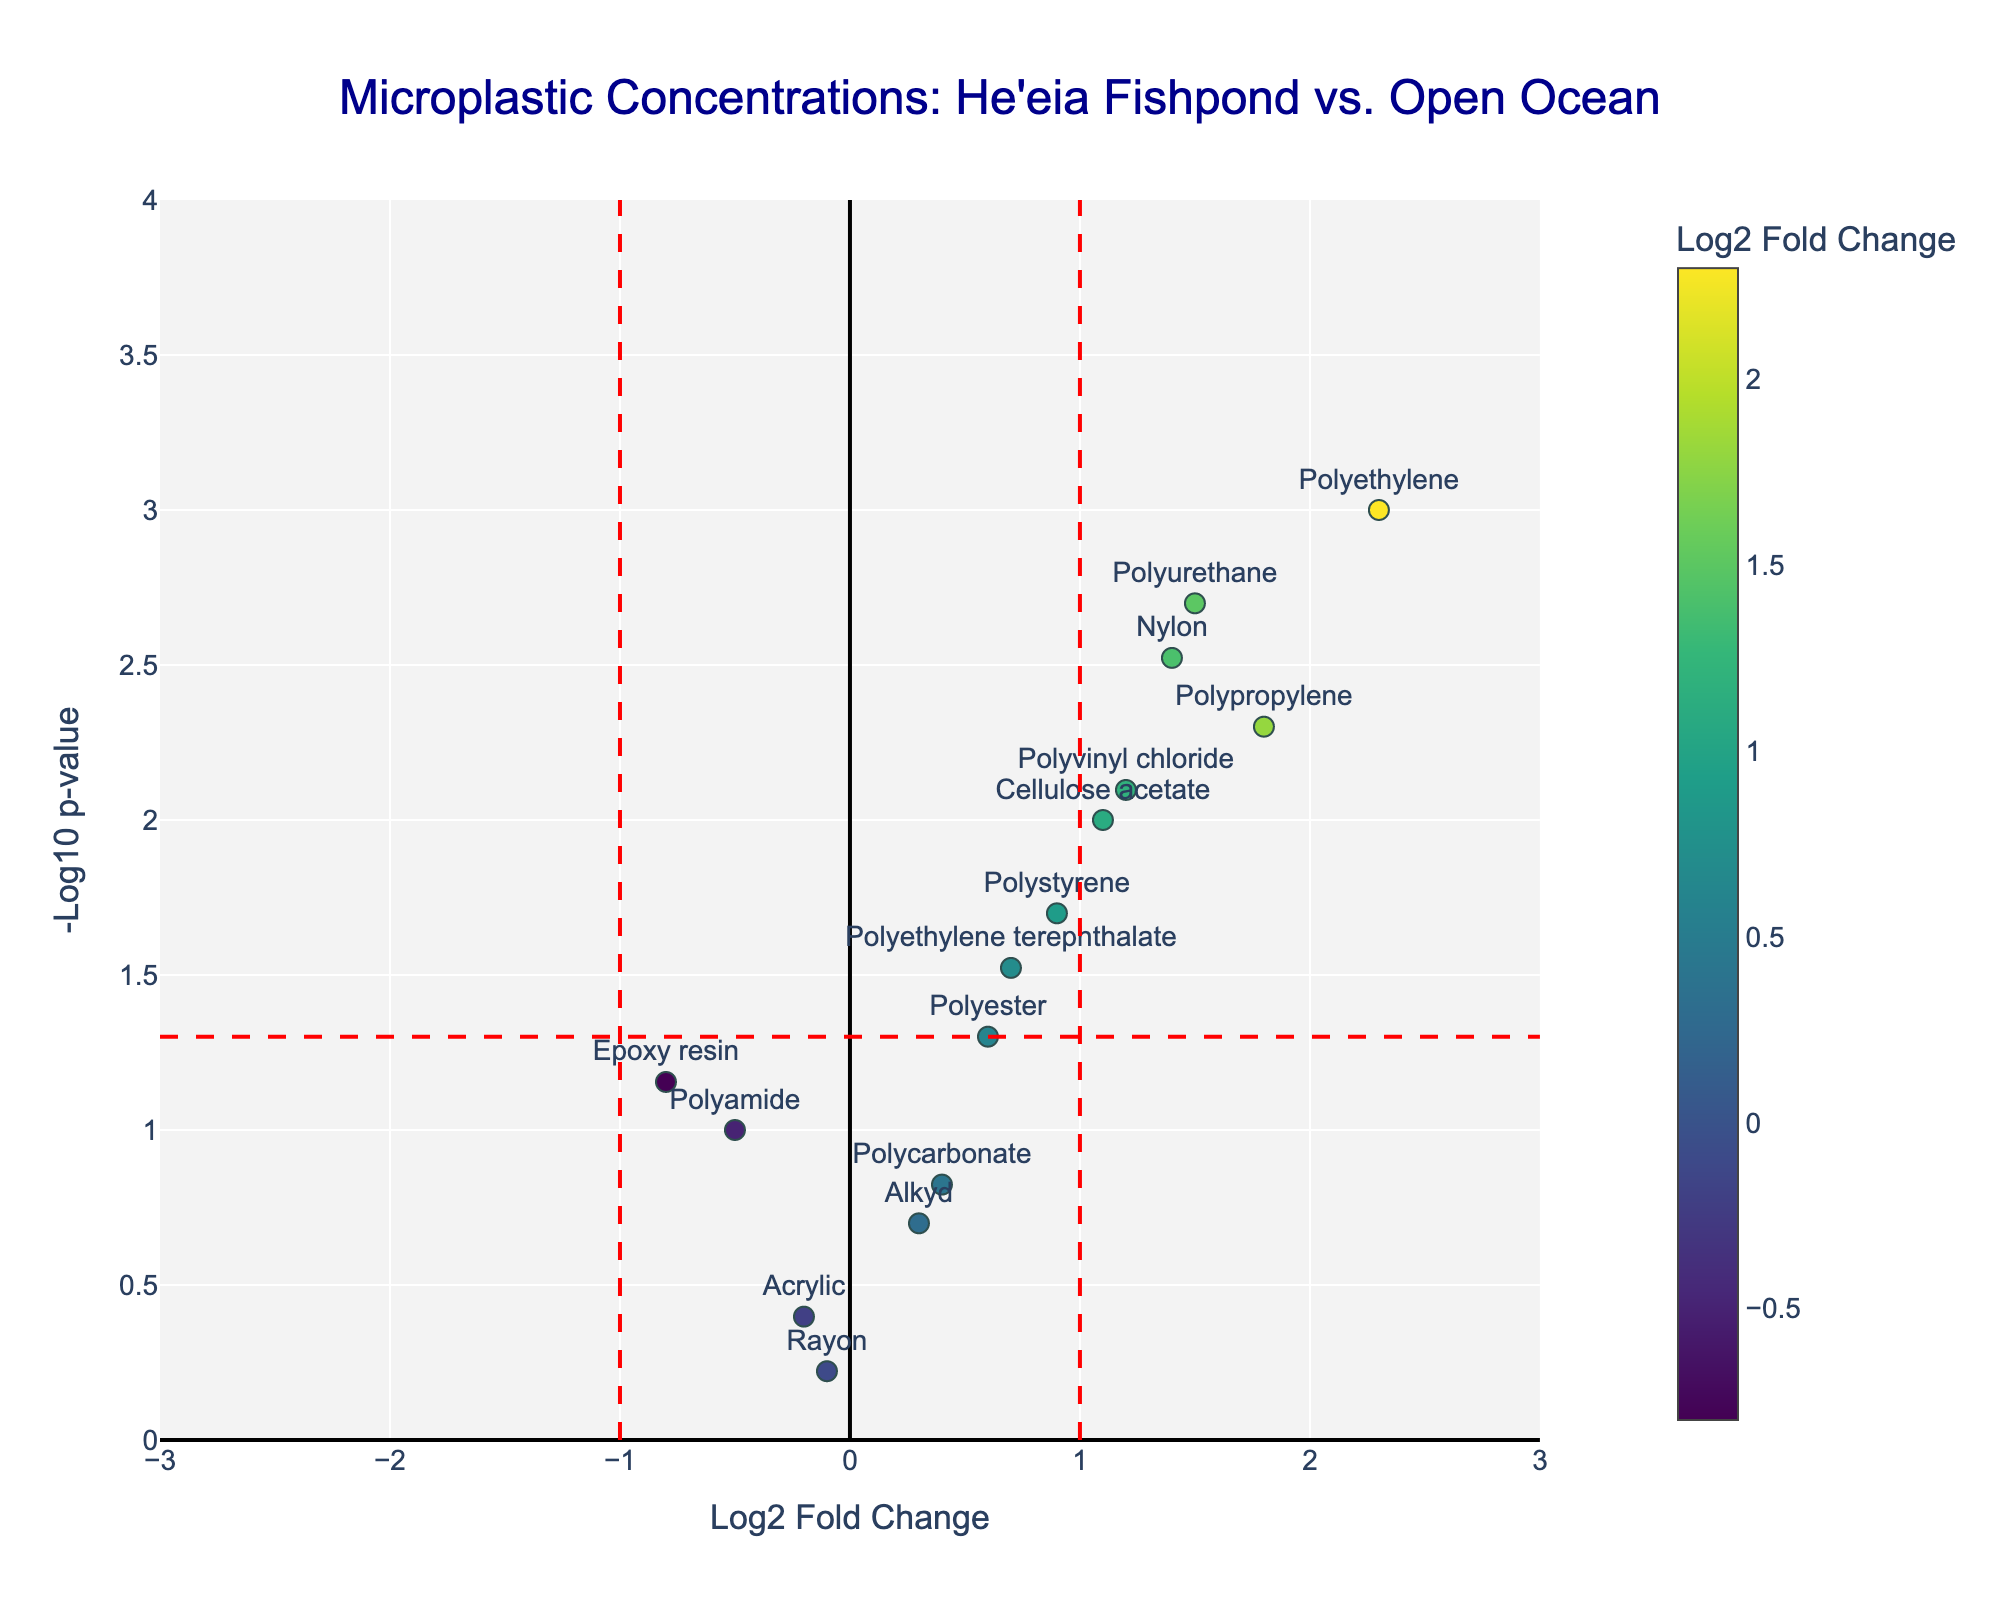What is the title of the plot? The title of the plot is typically positioned at the top center of the figure. In this case, the title reads "Microplastic Concentrations: Heʻeia Fishpond vs. Open Ocean".
Answer: Microplastic Concentrations: Heʻeia Fishpond vs. Open Ocean What does the x-axis represent? By looking at the axis label located along the horizontal axis, it can be concluded that the x-axis represents the "Log2 Fold Change".
Answer: Log2 Fold Change How are the color variations in the markers determined? The colors of the markers correspond to the "Log2 Fold Change" values. This can be inferred from the color bar which is labeled as "Log2 Fold Change".
Answer: Based on Log2 Fold Change Which microplastic type has the highest -Log10 p-value? Look for the data point that is positioned the highest on the y-axis, which represents the -Log10 p-value. Here, Polyethylene is the highest at a -Log10 p-value of around 3.
Answer: Polyethylene Which microplastic shows a Log2 Fold Change of less than -0.5? Identify the markers located to the left of -0.5 on the x-axis. The microplastic type that fits this criterion is Epoxy resin.
Answer: Epoxy resin How many microplastic types have a Log2 Fold Change greater than 1? Count the data points that lie to the right of the 1 marker on the x-axis. These include Polyethylene, Polypropylene, Polyvinyl chloride, Polyurethane, Cellulose acetate, and Nylon.
Answer: 6 What does the red horizontal dashed line at y ≈ 1.3 represent? The red horizontal dashed line signifies the -Log10 p-value threshold of 0.05, which is at approximately 1.3, indicating the statistical significance level.
Answer: p-value threshold of 0.05 Which microplastic types have a p-value less than 0.05 and Log2 Fold Change between -1 and 1? Find the points within the x-axis range of -1 to 1 and above the red horizontal line (y ≈ 1.3). The microplastic types are Polystyrene, Polyethylene terephthalate, and Polyester.
Answer: Polystyrene, Polyethylene terephthalate, Polyester Which microplastics are most significant in showing a difference between Heʻeia Fishpond and the open ocean? Identify markers above the red horizontal line (p-value < 0.05) indicating statistical significance. Focus on those with the highest -Log10 p-values. Significant microplastics include Polyethylene, Polypropylene, Polyvinyl chloride, Polyurethane, Cellulose acetate, and Nylon.
Answer: Polyethylene, Polypropylene, Polyvinyl chloride, Polyurethane, Cellulose acetate, Nylon 